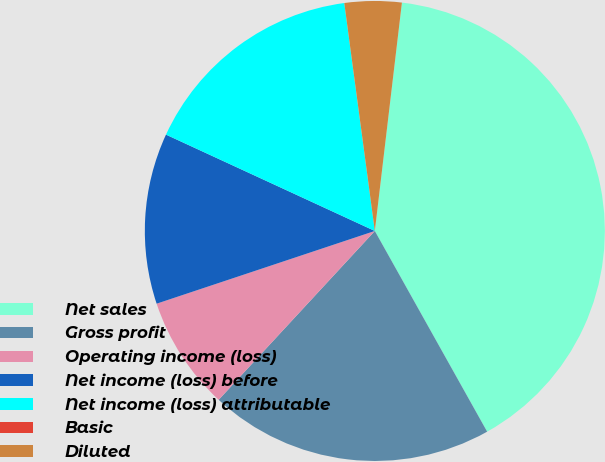Convert chart to OTSL. <chart><loc_0><loc_0><loc_500><loc_500><pie_chart><fcel>Net sales<fcel>Gross profit<fcel>Operating income (loss)<fcel>Net income (loss) before<fcel>Net income (loss) attributable<fcel>Basic<fcel>Diluted<nl><fcel>40.0%<fcel>20.0%<fcel>8.0%<fcel>12.0%<fcel>16.0%<fcel>0.0%<fcel>4.0%<nl></chart> 